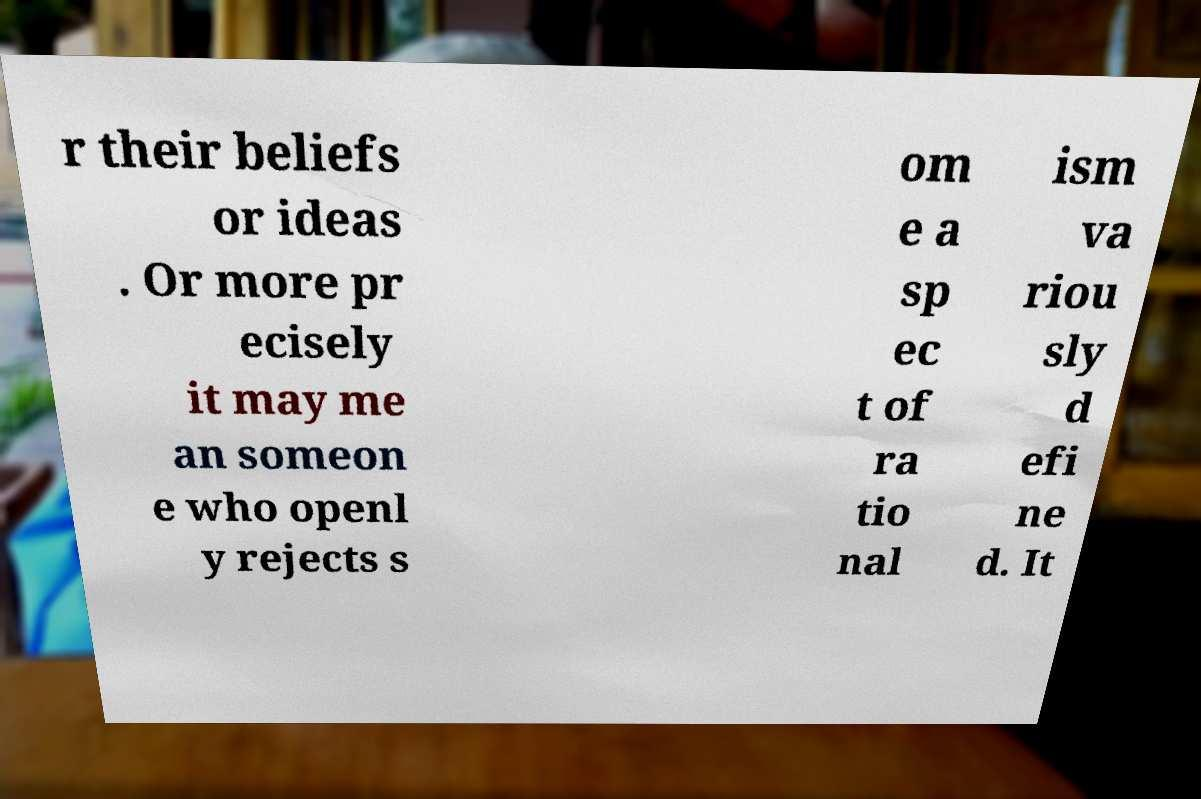Can you read and provide the text displayed in the image?This photo seems to have some interesting text. Can you extract and type it out for me? r their beliefs or ideas . Or more pr ecisely it may me an someon e who openl y rejects s om e a sp ec t of ra tio nal ism va riou sly d efi ne d. It 